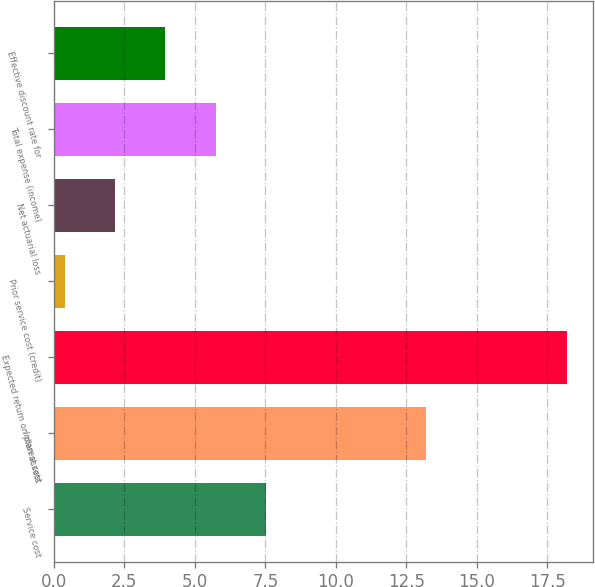Convert chart to OTSL. <chart><loc_0><loc_0><loc_500><loc_500><bar_chart><fcel>Service cost<fcel>Interest cost<fcel>Expected return on plan assets<fcel>Prior service cost (credit)<fcel>Net actuarial loss<fcel>Total expense (income)<fcel>Effective discount rate for<nl><fcel>7.52<fcel>13.2<fcel>18.2<fcel>0.4<fcel>2.18<fcel>5.74<fcel>3.96<nl></chart> 